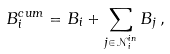<formula> <loc_0><loc_0><loc_500><loc_500>B _ { i } ^ { c u m } = B _ { i } + \sum _ { j \in { \mathcal { N } } _ { i } ^ { i n } } B _ { j } \, ,</formula> 